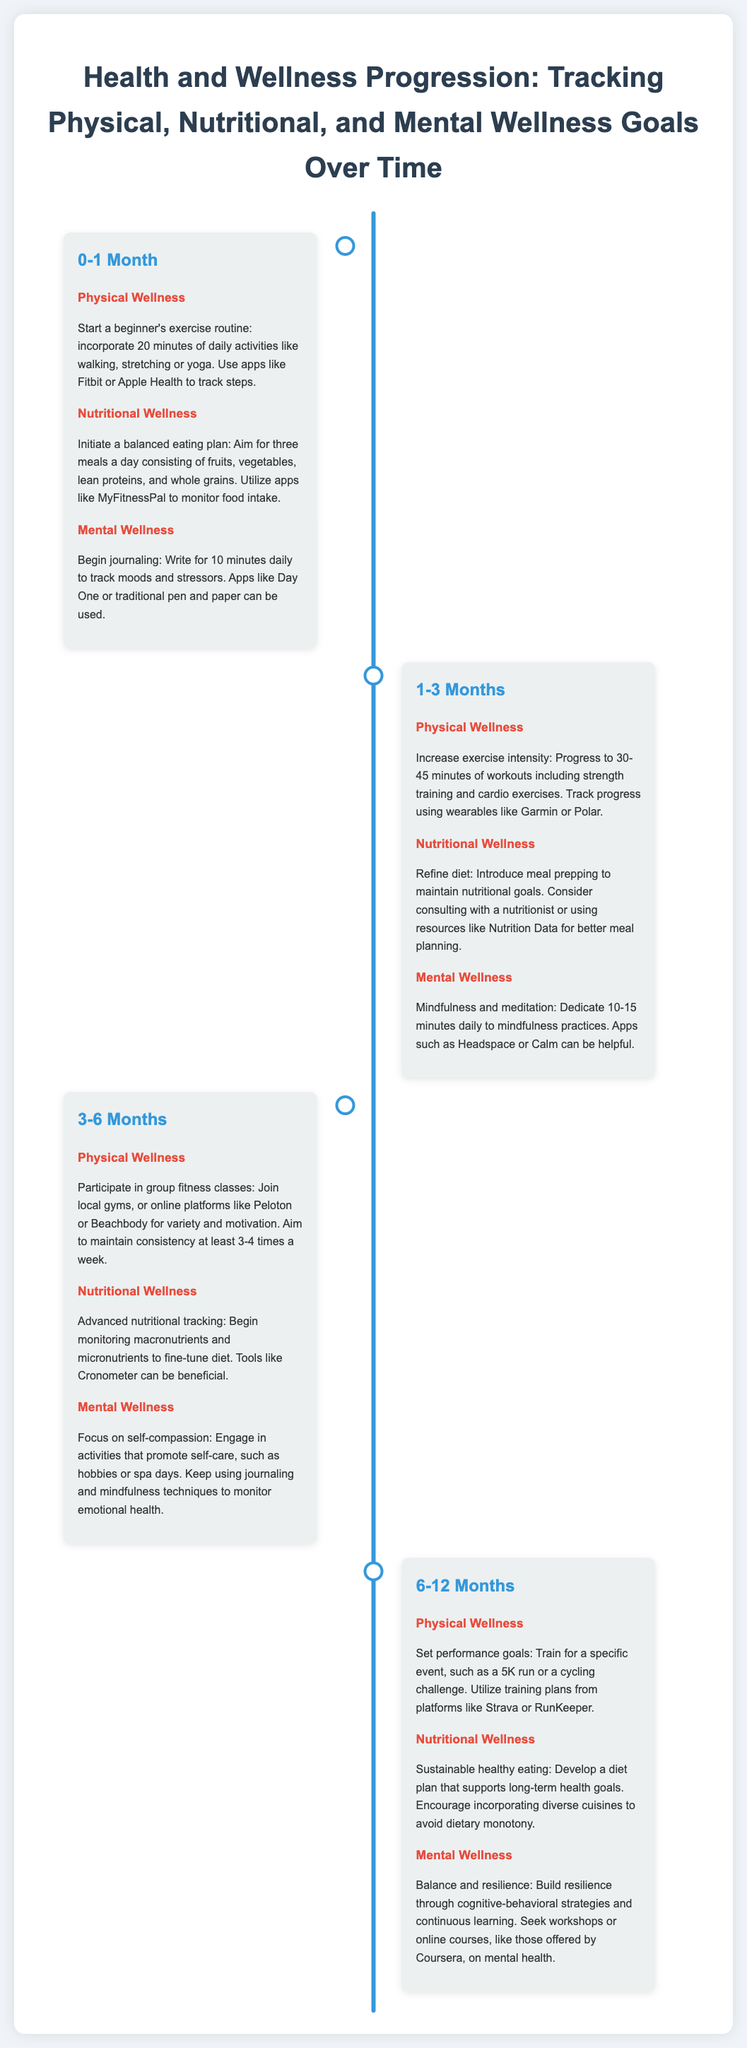What activities are recommended for Physical Wellness in the 0-1 Month phase? The document lists 20 minutes of daily activities like walking, stretching, or yoga.
Answer: walking, stretching, yoga How long should meals consist of fruits, vegetables, lean proteins, and whole grains in the 0-1 Month phase? The document specifies aiming for three meals a day.
Answer: three meals What should be introduced for Mental Wellness in the 1-3 Months phase? The document suggests dedicating 10-15 minutes daily to mindfulness practices.
Answer: mindfulness practices What is the recommended frequency for group fitness classes in the 3-6 Months phase? The document advises maintaining consistency at least 3-4 times a week.
Answer: 3-4 times What type of event should one train for in the 6-12 Months phase? The document mentions training for a specific event, such as a 5K run or a cycling challenge.
Answer: 5K run What primary focus is suggested for self-care in the 3-6 Months phase? The document encourages engaging in activities that promote self-care, such as hobbies or spa days.
Answer: self-care What resources are mentioned for advanced nutritional tracking in the 3-6 Months phase? The document suggests using tools like Cronometer for tracking macronutrients and micronutrients.
Answer: Cronometer What type of strategies should be built for Mental Wellness in the 6-12 Months phase? The document states to build resilience through cognitive-behavioral strategies.
Answer: cognitive-behavioral strategies What type of infographics does this document represent? The document is a timeline infographic focused on health and wellness progression.
Answer: timeline infographic 